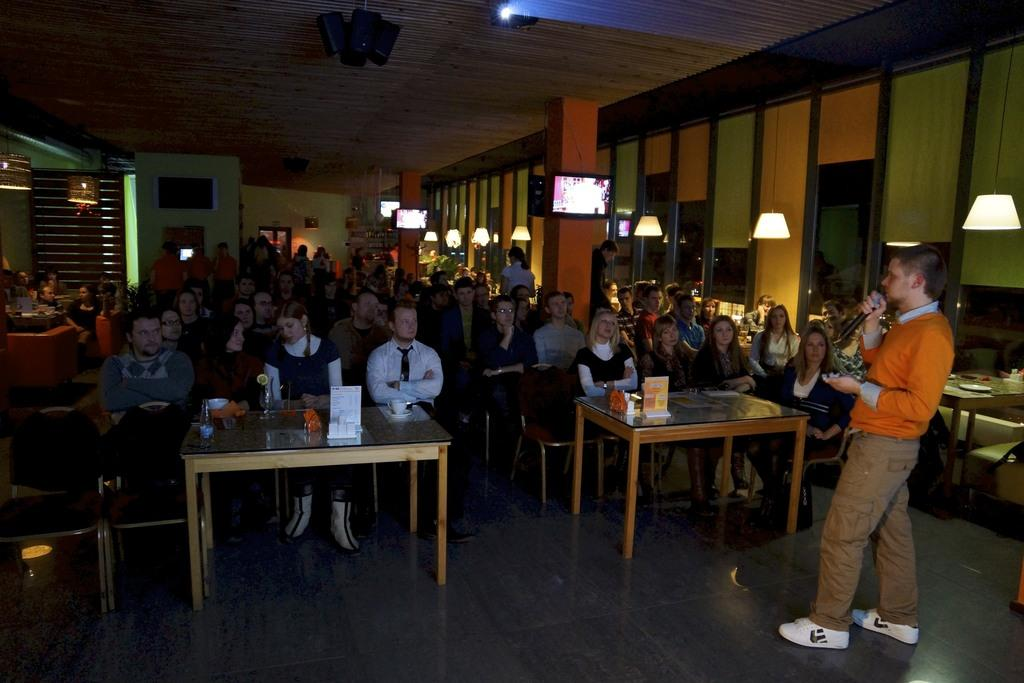What is the man on the right side of the image doing? The man is standing on the right side of the image and holding a microphone. What are the people in the middle of the image doing? The people are sitting on chairs in the middle of the image and listening to the man with the microphone. What objects can be seen in the image that provide light? There are lamps visible in the image. What type of flesh is being discussed by the man with the microphone? There is no mention of flesh in the image, and the man with the microphone is not discussing any type of flesh. How does the health of the people in the image compare to the health of the people outside the image? There is no information about the health of the people in the image or outside the image, so it cannot be compared. 